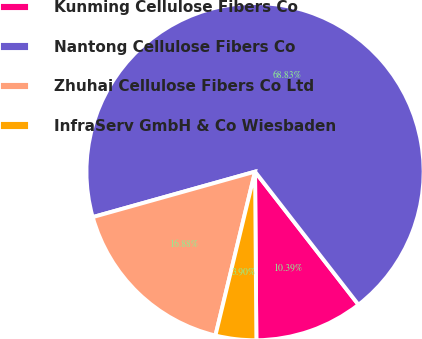<chart> <loc_0><loc_0><loc_500><loc_500><pie_chart><fcel>Kunming Cellulose Fibers Co<fcel>Nantong Cellulose Fibers Co<fcel>Zhuhai Cellulose Fibers Co Ltd<fcel>InfraServ GmbH & Co Wiesbaden<nl><fcel>10.39%<fcel>68.83%<fcel>16.88%<fcel>3.9%<nl></chart> 